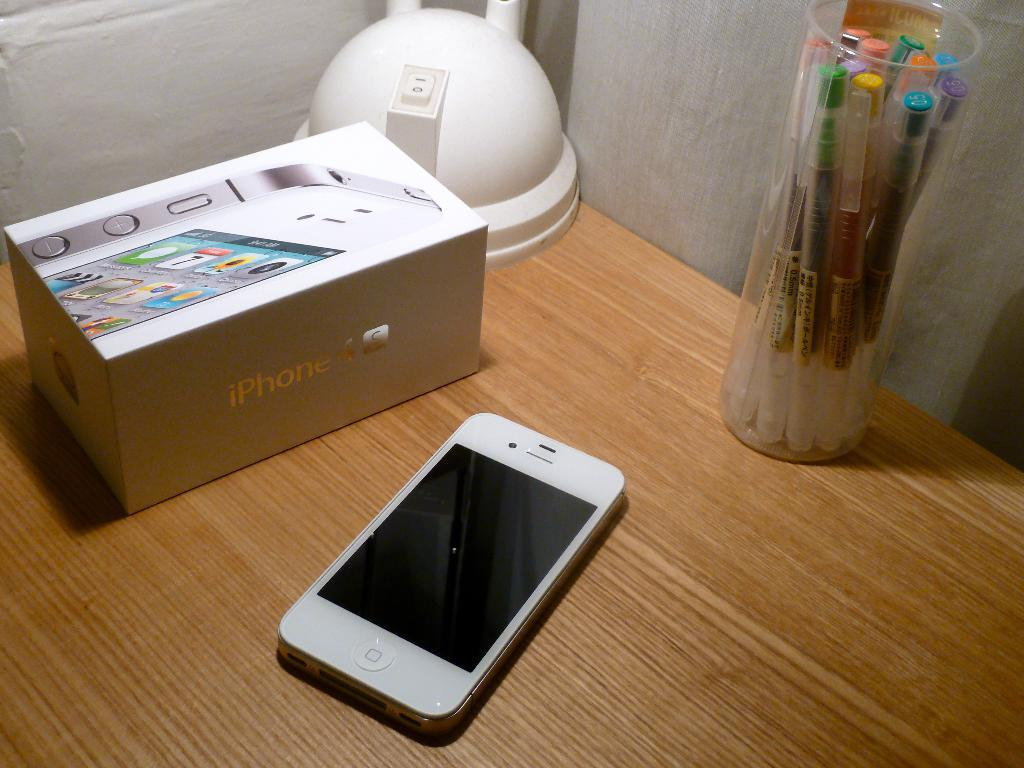Provide a one-sentence caption for the provided image. a white cell phone with a box reading iPHONE on a wood desk. 